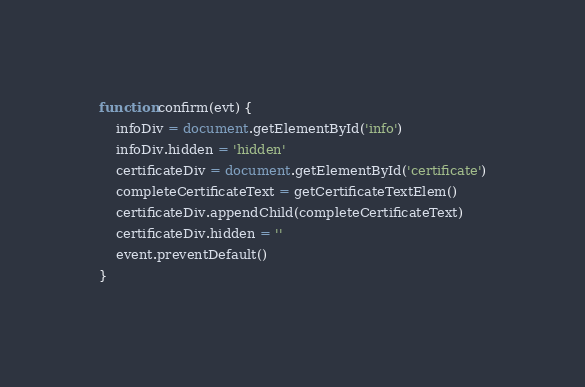<code> <loc_0><loc_0><loc_500><loc_500><_JavaScript_>function confirm(evt) {
    infoDiv = document.getElementById('info')
    infoDiv.hidden = 'hidden'
    certificateDiv = document.getElementById('certificate')
    completeCertificateText = getCertificateTextElem()
    certificateDiv.appendChild(completeCertificateText)
    certificateDiv.hidden = ''
    event.preventDefault()
}</code> 